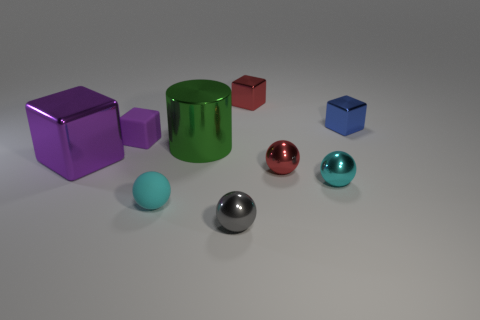Do the big metal thing that is to the left of the green metal cylinder and the rubber cube have the same color?
Your response must be concise. Yes. Are there any metal balls that have the same color as the tiny rubber ball?
Your answer should be compact. Yes. There is a metallic thing that is the same color as the matte cube; what size is it?
Make the answer very short. Large. Does the small blue shiny object have the same shape as the large purple shiny object behind the small gray metal sphere?
Provide a short and direct response. Yes. There is a cube that is the same size as the green object; what is its color?
Keep it short and to the point. Purple. Are there fewer purple objects on the left side of the big green metallic cylinder than small balls on the left side of the small cyan metallic thing?
Your response must be concise. Yes. What is the shape of the small red thing that is in front of the metallic block on the left side of the ball to the left of the gray ball?
Ensure brevity in your answer.  Sphere. There is a tiny cube to the left of the red block; is its color the same as the metallic thing that is on the left side of the big green metallic cylinder?
Provide a short and direct response. Yes. There is a object that is the same color as the small matte ball; what is its shape?
Offer a terse response. Sphere. What number of metal things are big gray things or small purple objects?
Keep it short and to the point. 0. 